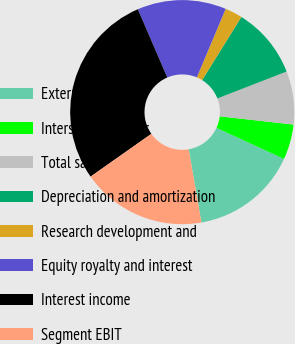Convert chart to OTSL. <chart><loc_0><loc_0><loc_500><loc_500><pie_chart><fcel>External sales<fcel>Intersegment sales<fcel>Total sales<fcel>Depreciation and amortization<fcel>Research development and<fcel>Equity royalty and interest<fcel>Interest income<fcel>Segment EBIT<nl><fcel>15.4%<fcel>5.09%<fcel>7.67%<fcel>10.25%<fcel>2.51%<fcel>12.82%<fcel>28.28%<fcel>17.98%<nl></chart> 